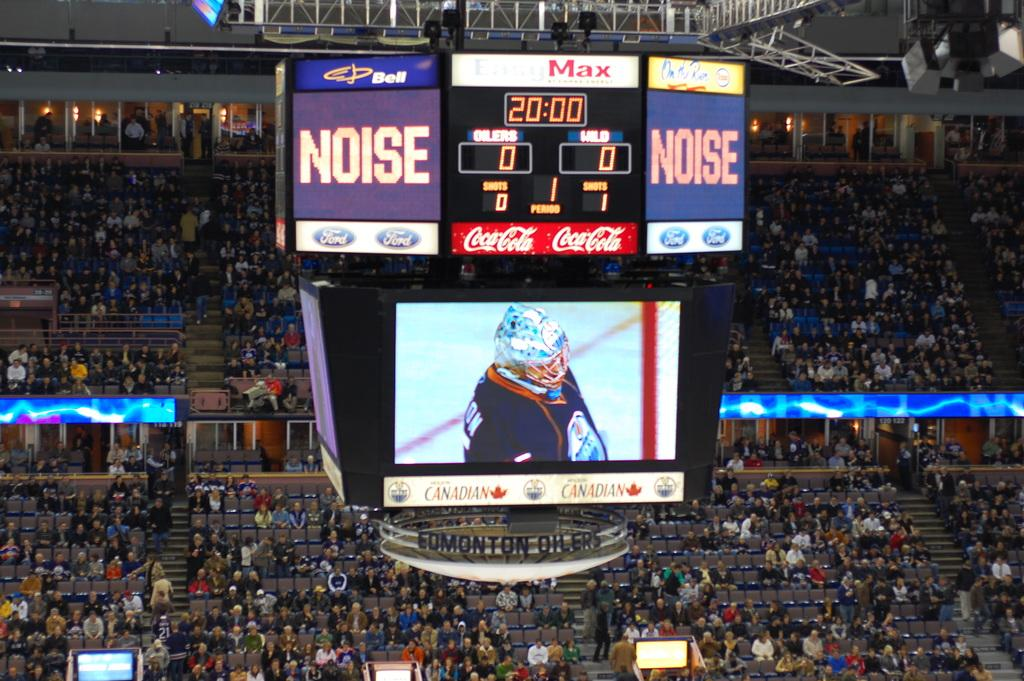<image>
Offer a succinct explanation of the picture presented. A large crowd a a sports game with the word NOISE on a screen at the top right. 